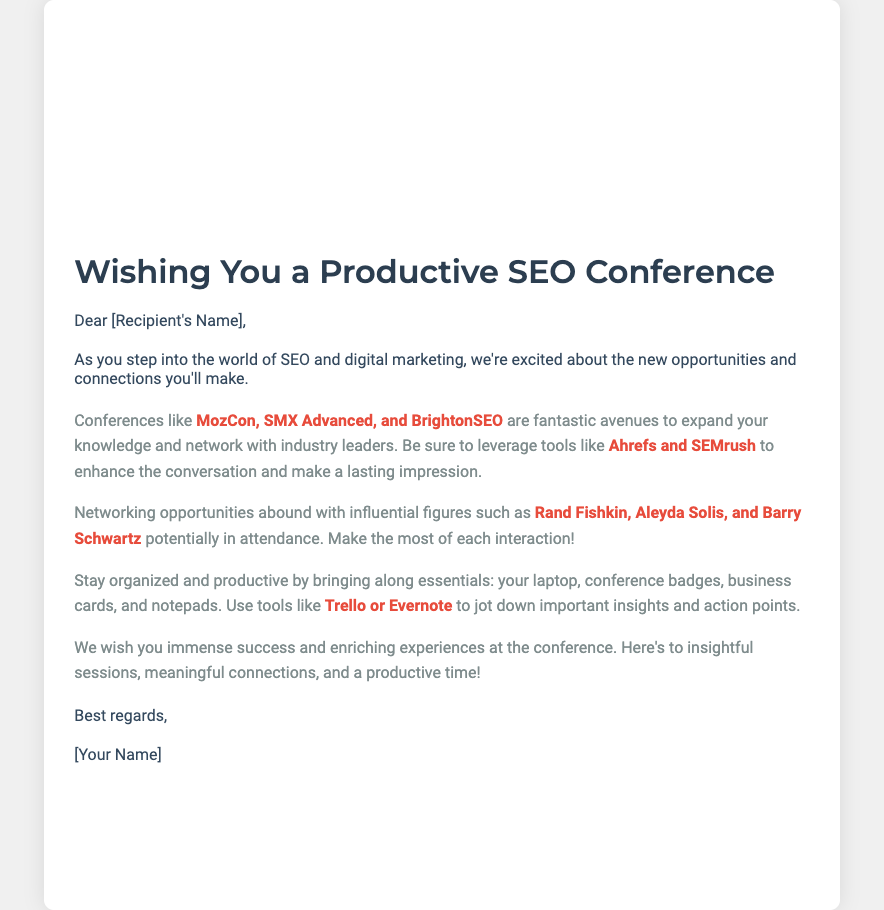What is the title of the card? The title is stated prominently at the top of the document.
Answer: Wishing You a Productive SEO Conference Who is the greeting addressed to? The greeting starts with "Dear [Recipient's Name]," indicating the recipient's name is to be inserted.
Answer: [Recipient's Name] Name one of the conferences mentioned in the card. The document lists several notable conferences in the body text.
Answer: MozCon What role do the highlighted tools like Ahrefs serve in the context of the document? The tools are mentioned as useful resources for attendees to enhance conversations.
Answer: Enhance the conversation Who are two influential figures mentioned for potential networking? The document mentions multiple influential figures for attendees to connect with.
Answer: Rand Fishkin, Aleyda Solis What should attendees bring to the conference according to the card? The document outlines several essentials to ensure productivity at the conference.
Answer: Laptop, conference badges, business cards What is the tone of the card? The language in the card conveys encouragement and well-wishes for success.
Answer: Encouraging What is the closing line in the card? The card concludes with a respectful and friendly closing.
Answer: Best regards 